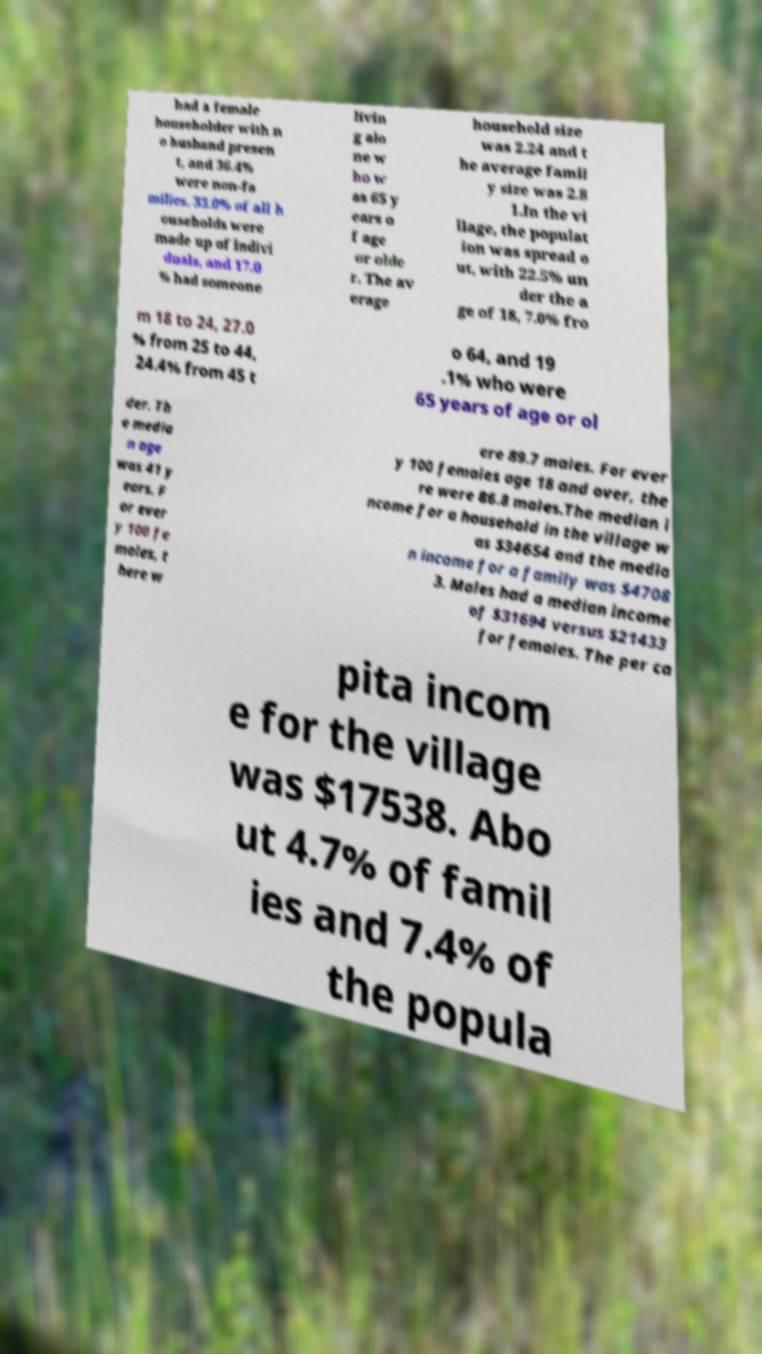Can you accurately transcribe the text from the provided image for me? had a female householder with n o husband presen t, and 36.4% were non-fa milies. 33.0% of all h ouseholds were made up of indivi duals, and 17.0 % had someone livin g alo ne w ho w as 65 y ears o f age or olde r. The av erage household size was 2.24 and t he average famil y size was 2.8 1.In the vi llage, the populat ion was spread o ut, with 22.5% un der the a ge of 18, 7.0% fro m 18 to 24, 27.0 % from 25 to 44, 24.4% from 45 t o 64, and 19 .1% who were 65 years of age or ol der. Th e media n age was 41 y ears. F or ever y 100 fe males, t here w ere 89.7 males. For ever y 100 females age 18 and over, the re were 86.8 males.The median i ncome for a household in the village w as $34654 and the media n income for a family was $4708 3. Males had a median income of $31694 versus $21433 for females. The per ca pita incom e for the village was $17538. Abo ut 4.7% of famil ies and 7.4% of the popula 